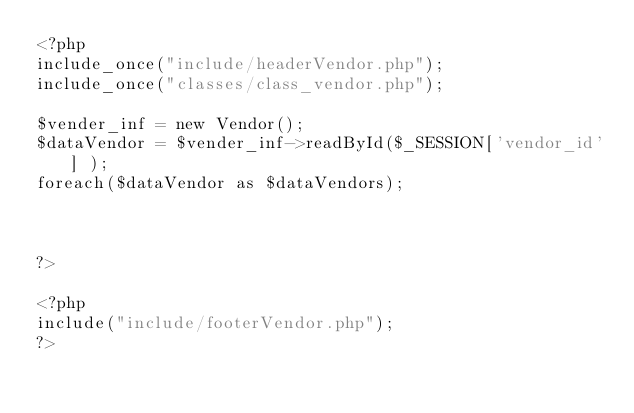<code> <loc_0><loc_0><loc_500><loc_500><_PHP_><?php
include_once("include/headerVendor.php");
include_once("classes/class_vendor.php");

$vender_inf = new Vendor();
$dataVendor = $vender_inf->readById($_SESSION['vendor_id'] );
foreach($dataVendor as $dataVendors);



?>
    
<?php
include("include/footerVendor.php");
?>



</code> 